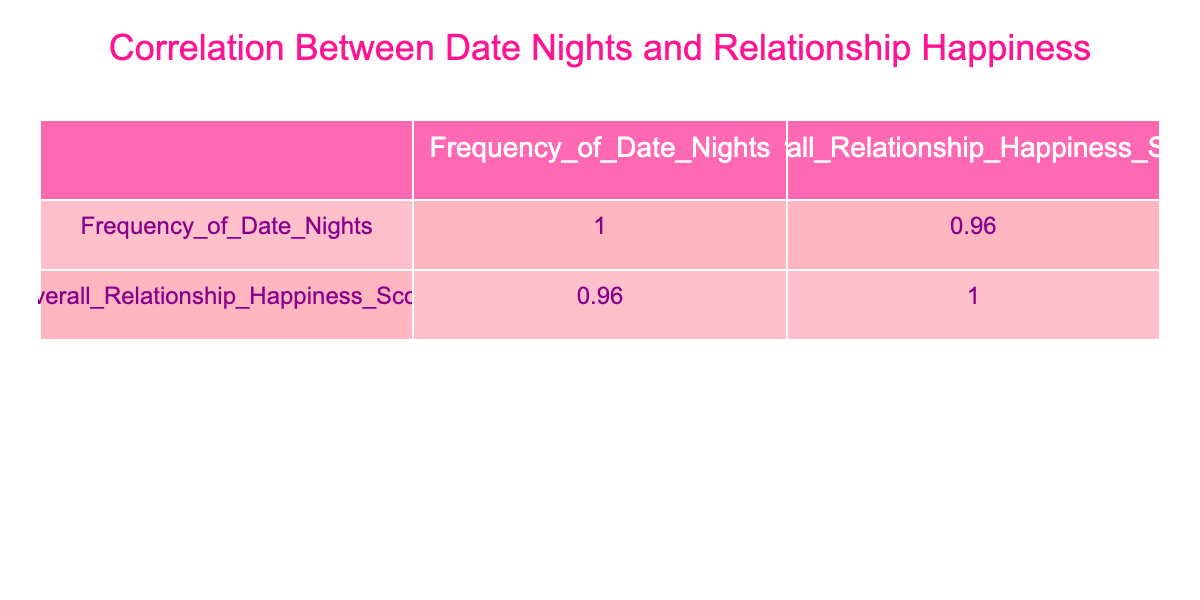What is the highest Overall Relationship Happiness Score? By checking the "Overall Relationship Happiness Score" column, we can see multiple scores listed. The highest score among these is 98, attributed to Catherine.
Answer: 98 What is the Frequency of Date Nights for the partner with the lowest Overall Relationship Happiness Score? We look for the lowest score in the "Overall Relationship Happiness Score" column, which is 50 for Jack. Then, we find the corresponding "Frequency of Date Nights," which is 1.
Answer: 1 Is there a partner with a Frequency of Date Nights of 10? Scanning the "Frequency of Date Nights" column, we find that both Emily and Olivia have a value of 10, indicating that there are indeed partners with that frequency.
Answer: Yes What is the average Frequency of Date Nights for all partners? We add up all the "Frequency of Date Nights" values: 8 + 4 + 12 + 6 + 10 + 2 + 5 + 3 + 9 + 1 + 7 + 11 + 6 + 4 + 10 = 78. Then we divide this sum by the number of partners (15), giving us an average of 78/15 = 5.2.
Answer: 5.2 How many partners have an Overall Relationship Happiness Score greater than 85? We check the scores and count each partner with a score greater than 85. These partners are: Alice (95), Catherine (98), Emily (90), Isabella (92), Liam (94), and Olivia (88), totaling 6 partners.
Answer: 6 What is the relationship between Frequency of Date Nights and Overall Relationship Happiness Score according to the correlation result? The correlation coefficient will tell us how strongly the two variables are related. By examining the correlation table, we notice that the coefficient is positive, suggesting a strong positive relationship: as date nights increase, happiness scores also tend to increase.
Answer: Positive correlation What is the difference in Overall Relationship Happiness Score between the partner with the most frequency of date nights and the one with the least? The partner with the most date nights is Catherine with a score of 98, and the partner with the least is Jack with a score of 50. We find the difference: 98 - 50 = 48.
Answer: 48 Do partners with more Frequency of Date Nights always have a higher Overall Relationship Happiness Score? By analyzing the table, we see that while there's a general trend, it is not always true. For instance, Frank with 2 date nights has a score of 55, while Grace has 5 date nights with a higher score of 75. Thus, it is not always the case.
Answer: No 